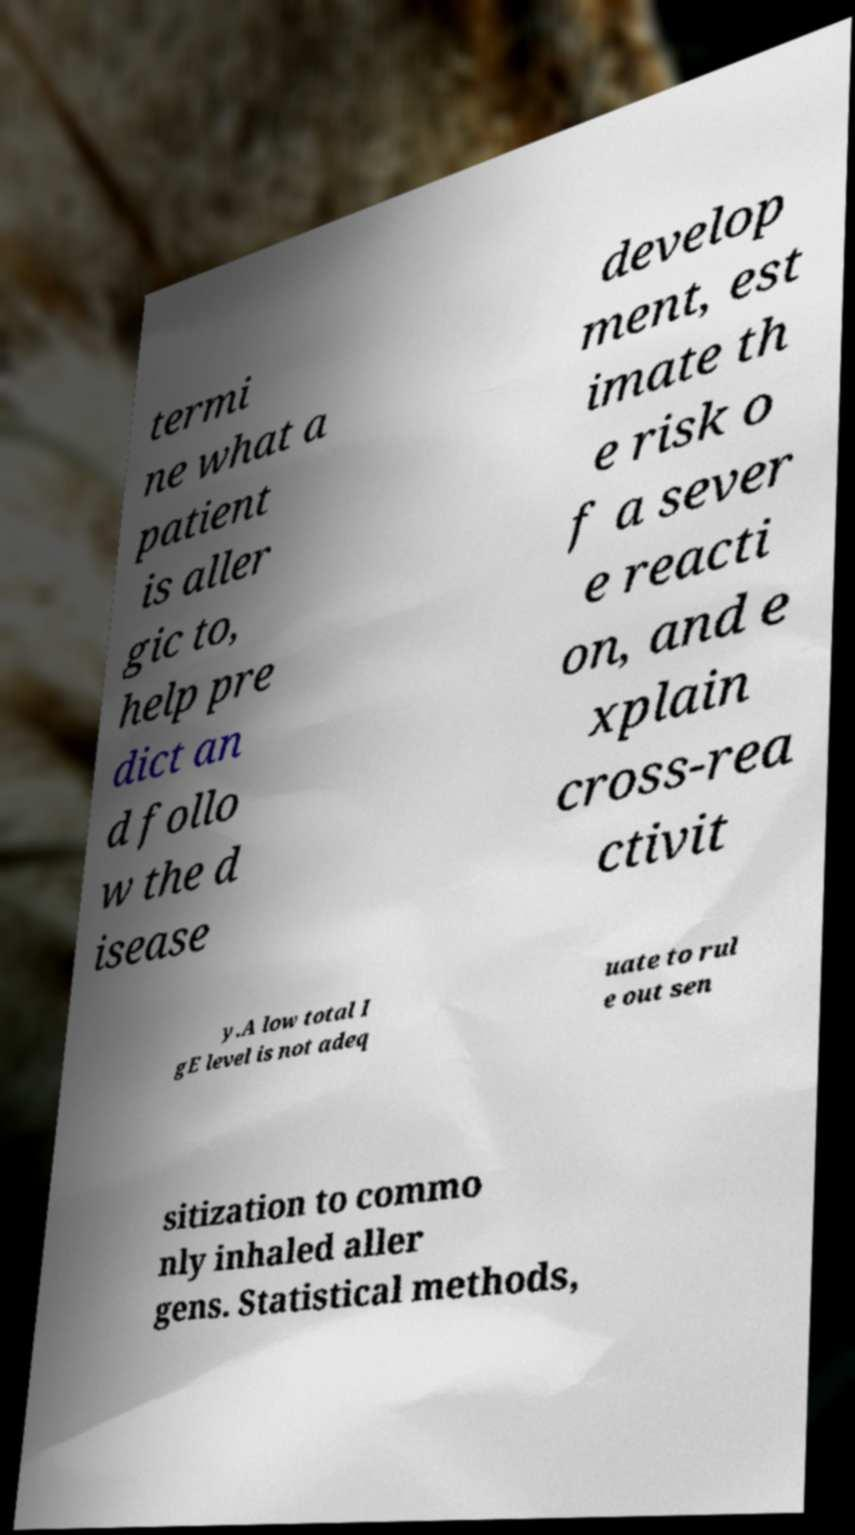Could you assist in decoding the text presented in this image and type it out clearly? termi ne what a patient is aller gic to, help pre dict an d follo w the d isease develop ment, est imate th e risk o f a sever e reacti on, and e xplain cross-rea ctivit y.A low total I gE level is not adeq uate to rul e out sen sitization to commo nly inhaled aller gens. Statistical methods, 